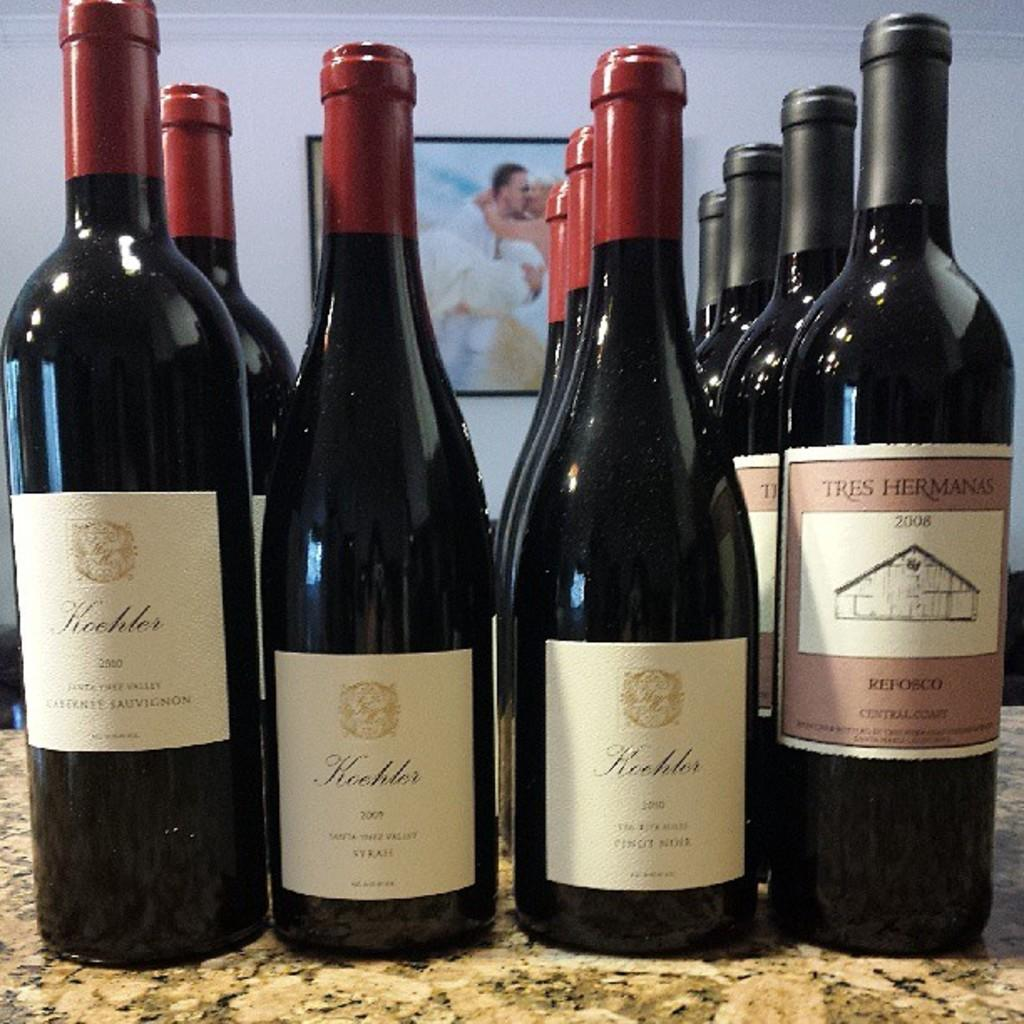Provide a one-sentence caption for the provided image. A bottle of Tisdale wine with a chicken cork in it. 